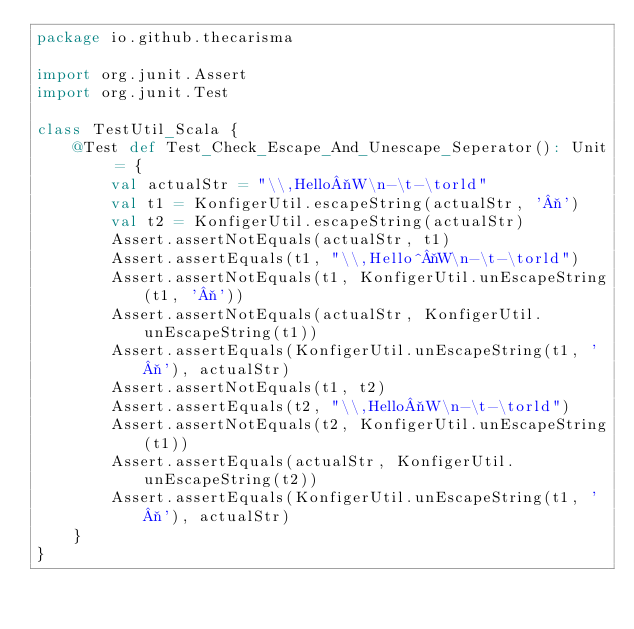Convert code to text. <code><loc_0><loc_0><loc_500><loc_500><_Scala_>package io.github.thecarisma

import org.junit.Assert
import org.junit.Test

class TestUtil_Scala {
    @Test def Test_Check_Escape_And_Unescape_Seperator(): Unit = {
        val actualStr = "\\,Hello¬W\n-\t-\torld"
        val t1 = KonfigerUtil.escapeString(actualStr, '¬')
        val t2 = KonfigerUtil.escapeString(actualStr)
        Assert.assertNotEquals(actualStr, t1)
        Assert.assertEquals(t1, "\\,Hello^¬W\n-\t-\torld")
        Assert.assertNotEquals(t1, KonfigerUtil.unEscapeString(t1, '¬'))
        Assert.assertNotEquals(actualStr, KonfigerUtil.unEscapeString(t1))
        Assert.assertEquals(KonfigerUtil.unEscapeString(t1, '¬'), actualStr)
        Assert.assertNotEquals(t1, t2)
        Assert.assertEquals(t2, "\\,Hello¬W\n-\t-\torld")
        Assert.assertNotEquals(t2, KonfigerUtil.unEscapeString(t1))
        Assert.assertEquals(actualStr, KonfigerUtil.unEscapeString(t2))
        Assert.assertEquals(KonfigerUtil.unEscapeString(t1, '¬'), actualStr)
    }
}</code> 